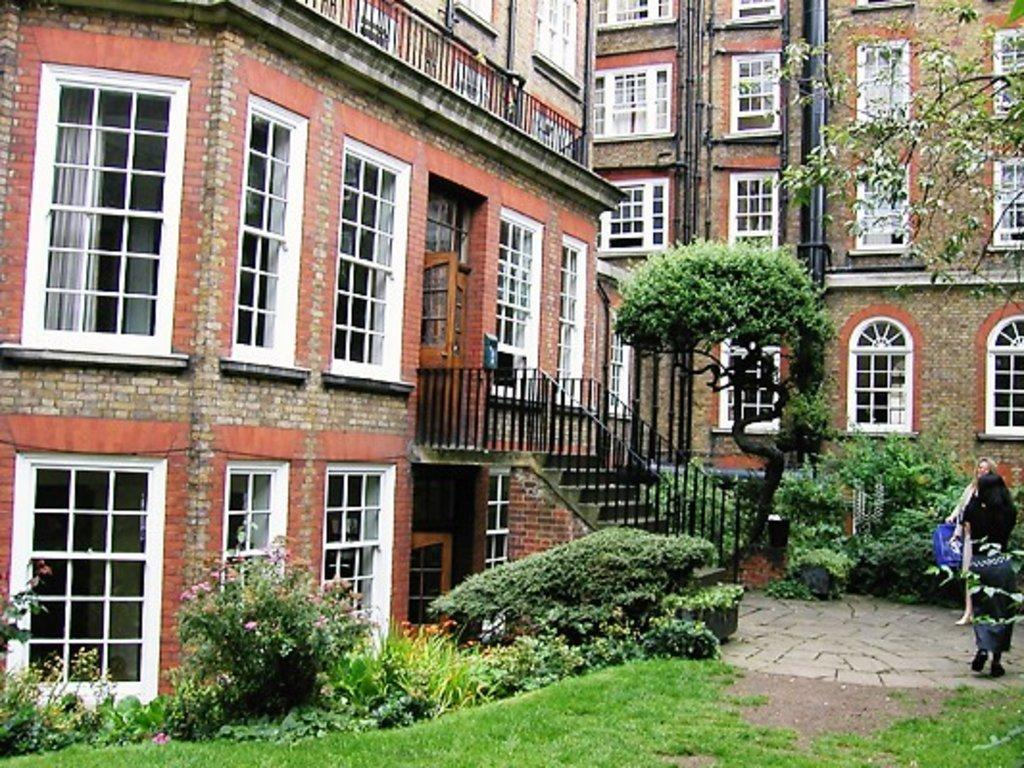What type of structures can be seen in the image? There are buildings in the image. What type of vegetation is present in the image? There are plants, trees, and flowers in the image. What architectural feature can be seen in the image? There are windows and stairs in the image. Are there any living beings in the image? Yes, there are persons in the image. What type of ground surface is visible in the image? There is grass in the image. How many pizzas are being delivered by the laborer in the image? There is no laborer or pizza present in the image. What historical event is depicted in the image? There is no historical event depicted in the image; it features buildings, plants, trees, flowers, windows, persons, and stairs. 